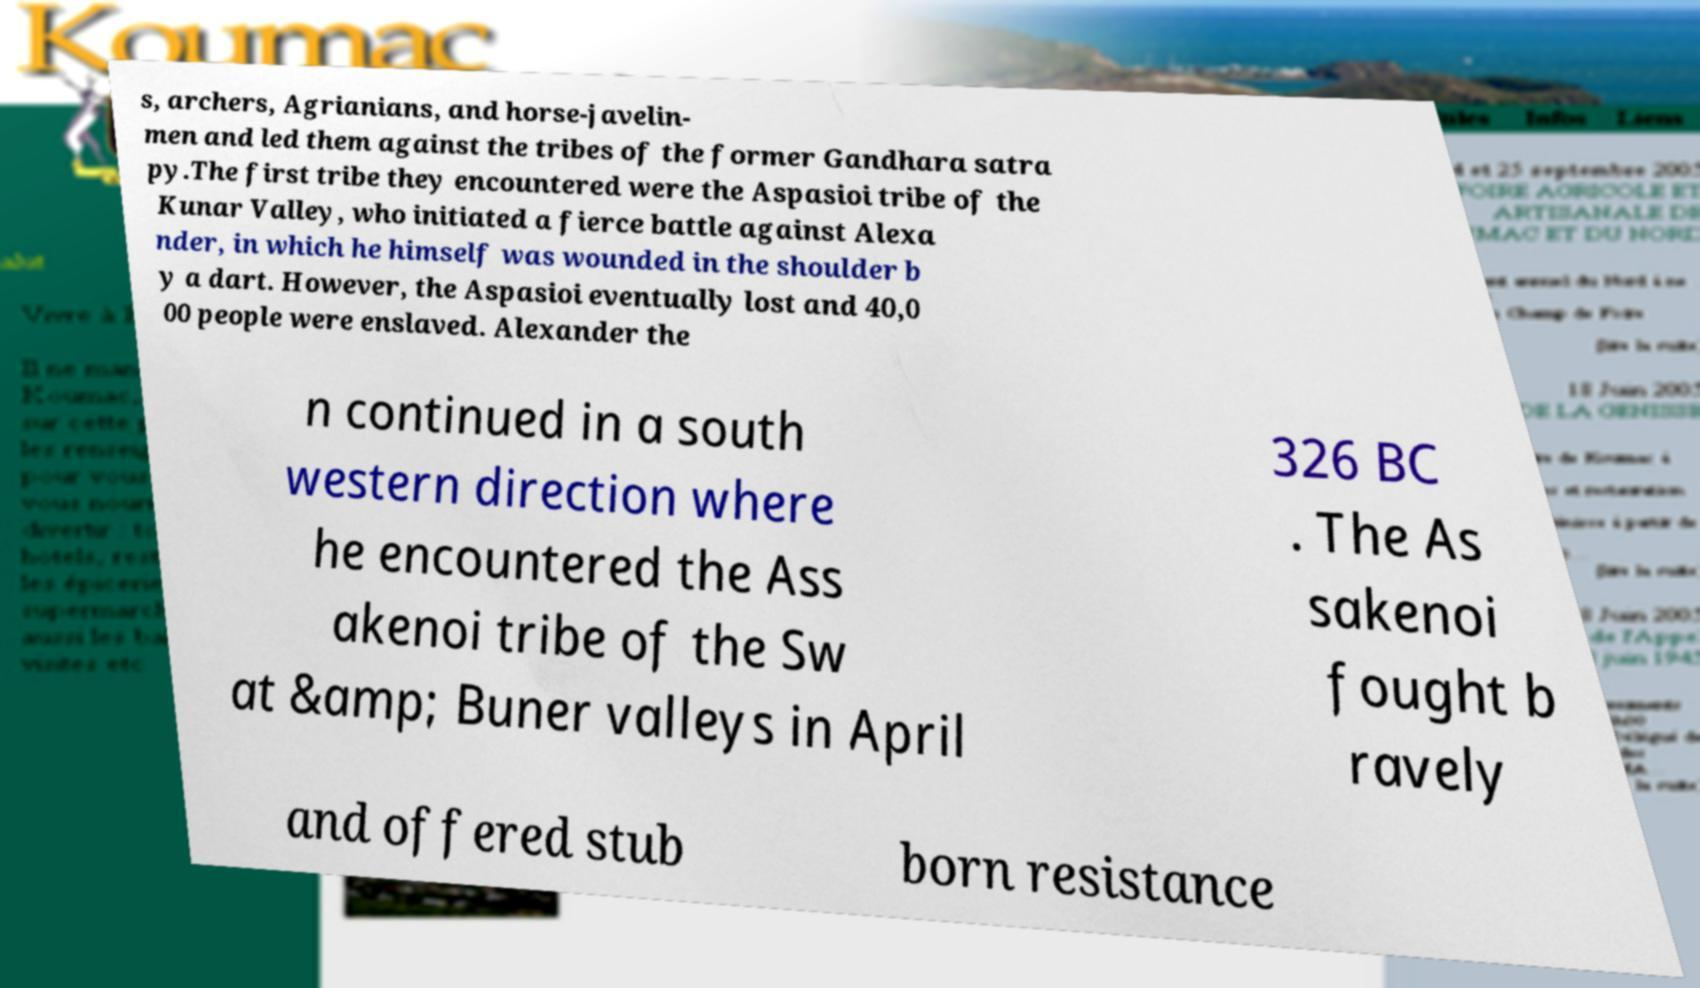Please read and relay the text visible in this image. What does it say? s, archers, Agrianians, and horse-javelin- men and led them against the tribes of the former Gandhara satra py.The first tribe they encountered were the Aspasioi tribe of the Kunar Valley, who initiated a fierce battle against Alexa nder, in which he himself was wounded in the shoulder b y a dart. However, the Aspasioi eventually lost and 40,0 00 people were enslaved. Alexander the n continued in a south western direction where he encountered the Ass akenoi tribe of the Sw at &amp; Buner valleys in April 326 BC . The As sakenoi fought b ravely and offered stub born resistance 